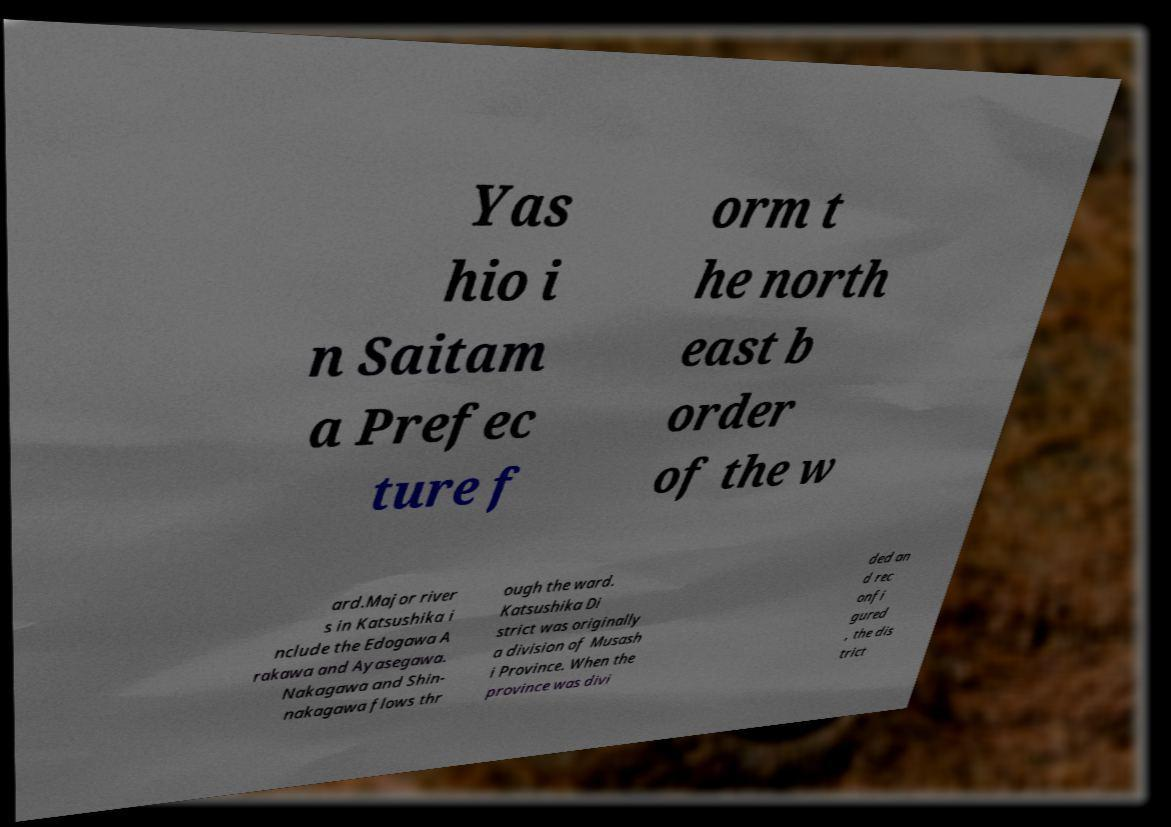I need the written content from this picture converted into text. Can you do that? Yas hio i n Saitam a Prefec ture f orm t he north east b order of the w ard.Major river s in Katsushika i nclude the Edogawa A rakawa and Ayasegawa. Nakagawa and Shin- nakagawa flows thr ough the ward. Katsushika Di strict was originally a division of Musash i Province. When the province was divi ded an d rec onfi gured , the dis trict 